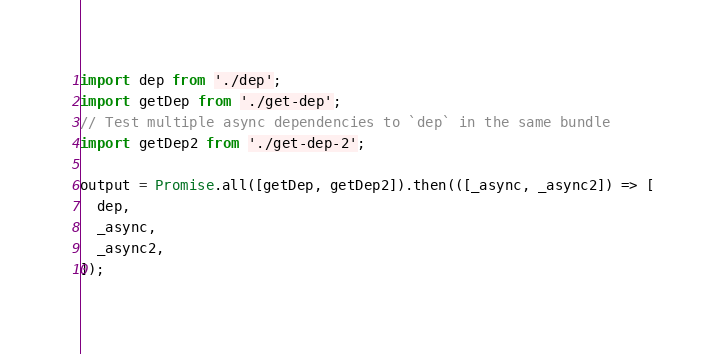<code> <loc_0><loc_0><loc_500><loc_500><_JavaScript_>import dep from './dep';
import getDep from './get-dep';
// Test multiple async dependencies to `dep` in the same bundle
import getDep2 from './get-dep-2';

output = Promise.all([getDep, getDep2]).then(([_async, _async2]) => [
  dep,
  _async,
  _async2,
]);
</code> 